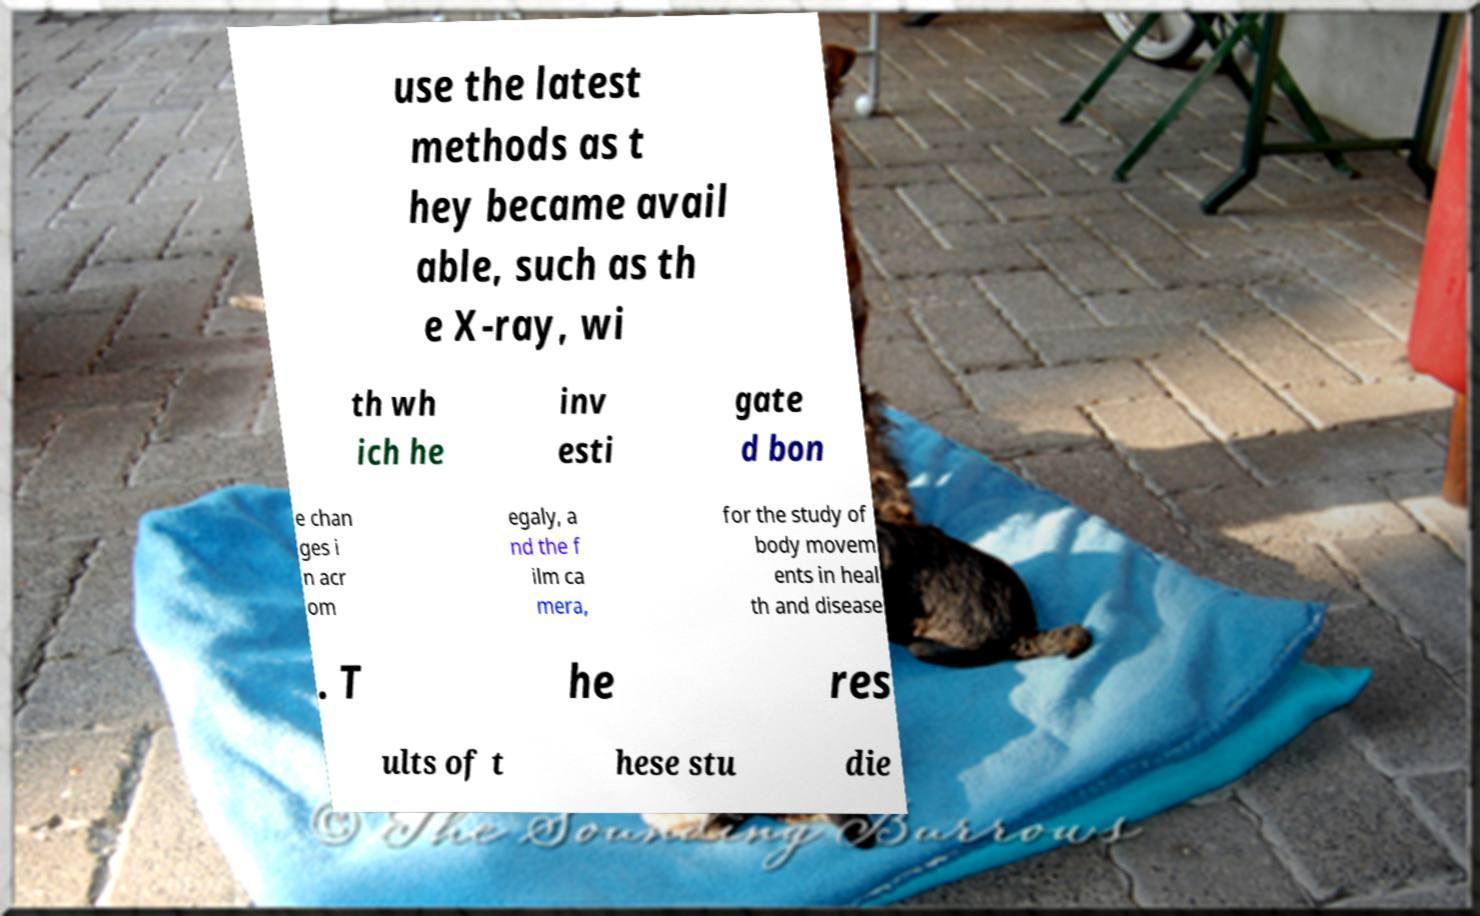Could you assist in decoding the text presented in this image and type it out clearly? use the latest methods as t hey became avail able, such as th e X-ray, wi th wh ich he inv esti gate d bon e chan ges i n acr om egaly, a nd the f ilm ca mera, for the study of body movem ents in heal th and disease . T he res ults of t hese stu die 